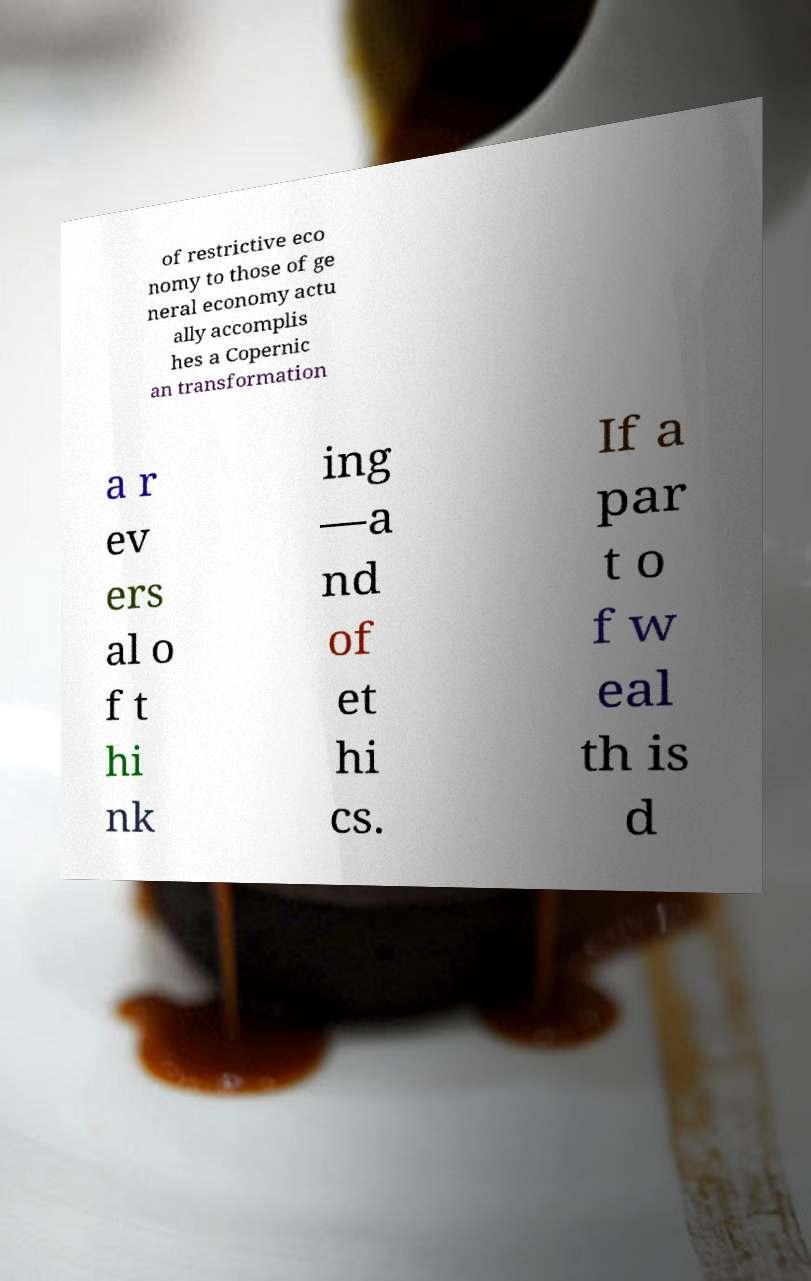Please read and relay the text visible in this image. What does it say? of restrictive eco nomy to those of ge neral economy actu ally accomplis hes a Copernic an transformation a r ev ers al o f t hi nk ing —a nd of et hi cs. If a par t o f w eal th is d 